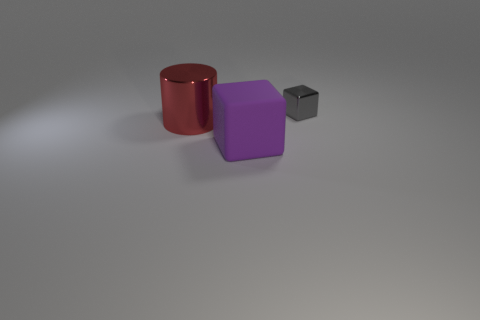What number of tiny gray things have the same material as the big purple block?
Make the answer very short. 0. Is the number of blocks greater than the number of large red objects?
Provide a short and direct response. Yes. How many cubes are behind the block on the right side of the purple cube?
Provide a succinct answer. 0. How many objects are either metal things in front of the small gray object or rubber things?
Your answer should be compact. 2. Are there any gray rubber objects that have the same shape as the big purple rubber object?
Give a very brief answer. No. There is a shiny object that is to the left of the small gray metal cube behind the large red object; what shape is it?
Offer a very short reply. Cylinder. What number of cylinders are either small metallic things or red shiny things?
Offer a very short reply. 1. There is a thing that is right of the big purple object; is it the same shape as the metal thing in front of the tiny gray thing?
Offer a very short reply. No. There is a object that is both behind the large purple object and to the right of the cylinder; what color is it?
Give a very brief answer. Gray. Do the cylinder and the object that is on the right side of the purple matte cube have the same color?
Your answer should be compact. No. 